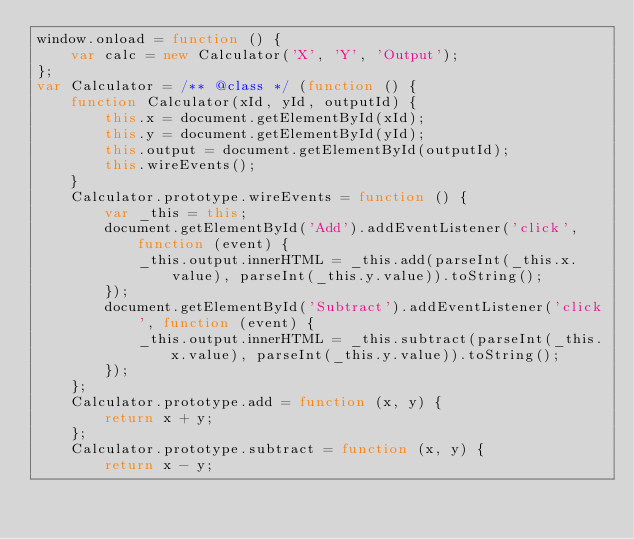<code> <loc_0><loc_0><loc_500><loc_500><_JavaScript_>window.onload = function () {
    var calc = new Calculator('X', 'Y', 'Output');
};
var Calculator = /** @class */ (function () {
    function Calculator(xId, yId, outputId) {
        this.x = document.getElementById(xId);
        this.y = document.getElementById(yId);
        this.output = document.getElementById(outputId);
        this.wireEvents();
    }
    Calculator.prototype.wireEvents = function () {
        var _this = this;
        document.getElementById('Add').addEventListener('click', function (event) {
            _this.output.innerHTML = _this.add(parseInt(_this.x.value), parseInt(_this.y.value)).toString();
        });
        document.getElementById('Subtract').addEventListener('click', function (event) {
            _this.output.innerHTML = _this.subtract(parseInt(_this.x.value), parseInt(_this.y.value)).toString();
        });
    };
    Calculator.prototype.add = function (x, y) {
        return x + y;
    };
    Calculator.prototype.subtract = function (x, y) {
        return x - y;</code> 